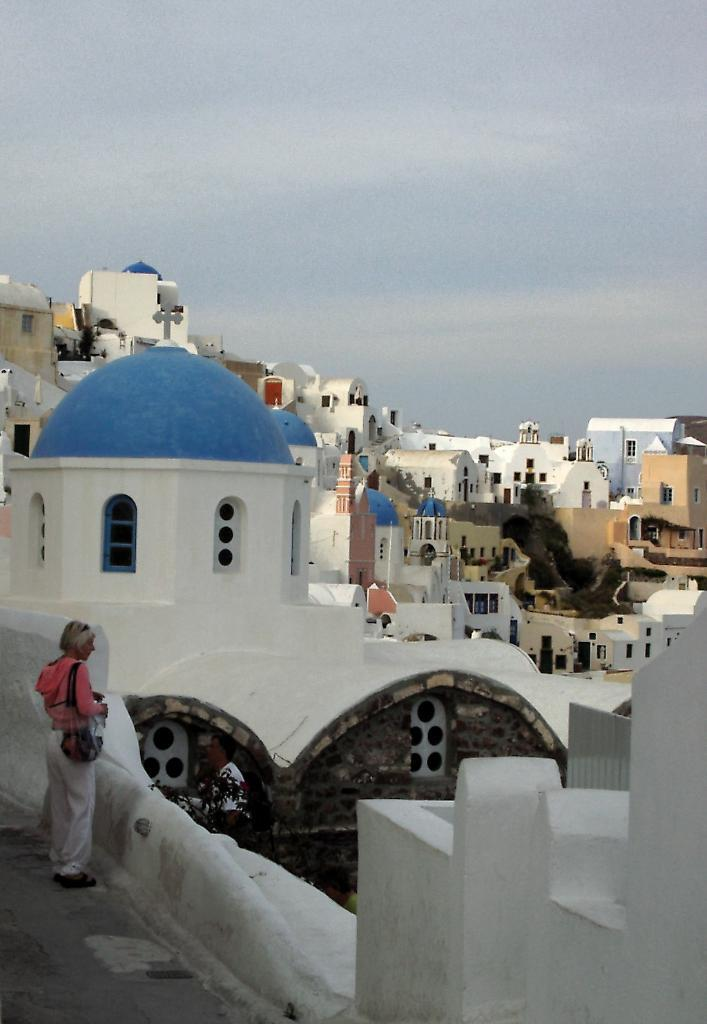What type of structures can be seen in the image? There are buildings in the image. What other natural elements are present in the image? There are trees in the image. Can you describe the person in the image? There is a person standing on the left side of the image. What is at the bottom of the image? There is a road at the bottom of the image. What is visible at the top of the image? The sky is visible at the top of the image. How many cakes are being sold by the person on the left side of the image? There are no cakes visible in the image, and the person is not selling anything. How many men are present in the image? The image does not specify the gender of the person on the left side, so we cannot determine the number of men present. 